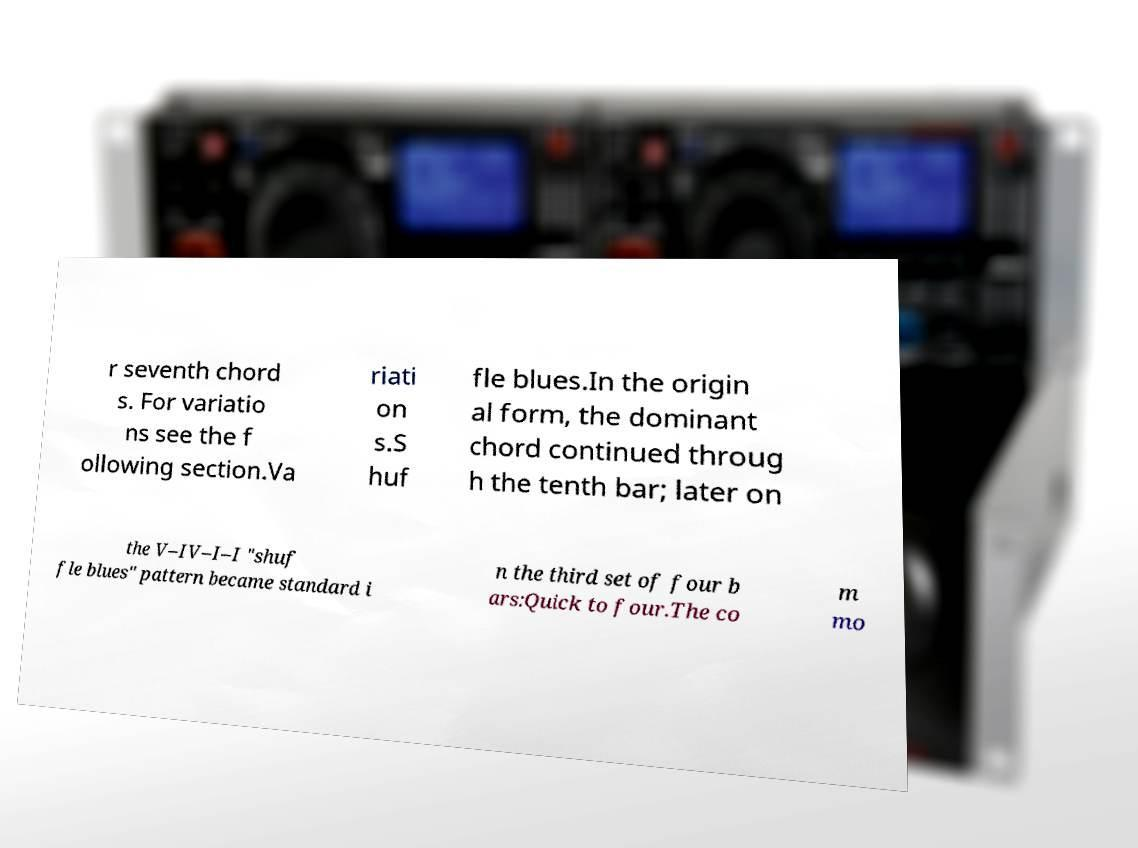Can you accurately transcribe the text from the provided image for me? r seventh chord s. For variatio ns see the f ollowing section.Va riati on s.S huf fle blues.In the origin al form, the dominant chord continued throug h the tenth bar; later on the V–IV–I–I "shuf fle blues" pattern became standard i n the third set of four b ars:Quick to four.The co m mo 